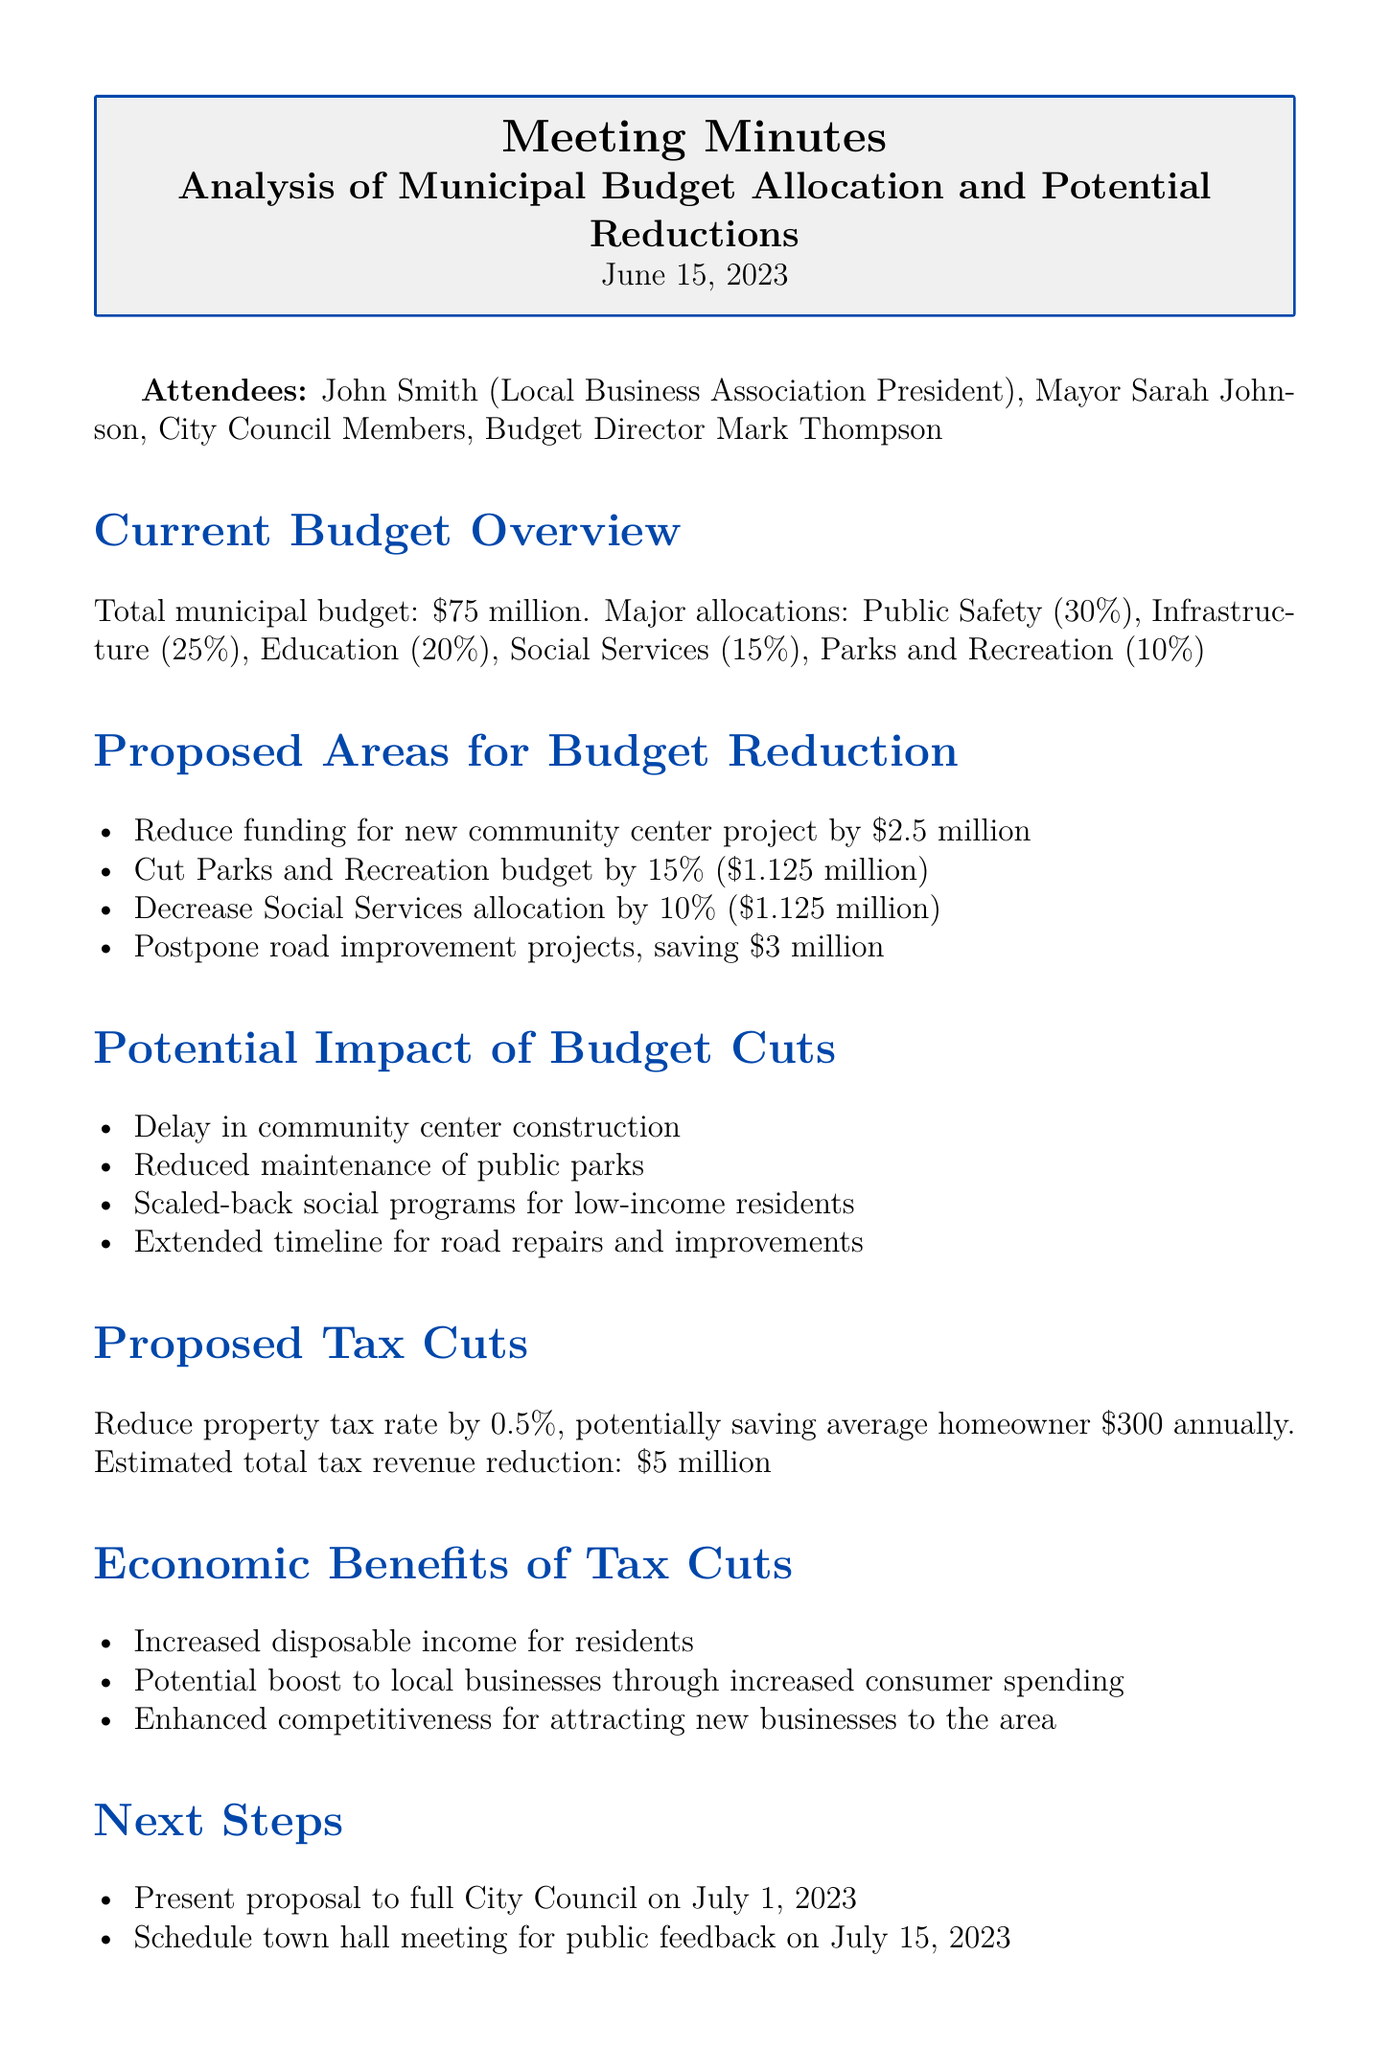what is the total municipal budget? The total municipal budget is clearly stated in the document as $75 million.
Answer: $75 million what percentage of the budget is allocated to Public Safety? The budget allocation for Public Safety is specifically mentioned as 30%.
Answer: 30% how much funding is proposed to reduce for the community center project? The document states a proposed reduction of $2.5 million for the community center project.
Answer: $2.5 million what is the potential annual savings for homeowners from the proposed tax cut? The document indicates that homeowners could save an average of $300 annually from the tax cut.
Answer: $300 what will be the estimated total tax revenue reduction? The document mentions that the estimated total tax revenue reduction will be $5 million.
Answer: $5 million what is one potential impact of the proposed budget cuts? It is mentioned that there will be a delay in community center construction as a potential impact of the budget cuts.
Answer: Delay in community center construction which date is scheduled for public feedback on the proposals? The document specifies the town hall meeting for public feedback is scheduled for July 15, 2023.
Answer: July 15, 2023 what is one economic benefit of the proposed tax cuts? One economic benefit mentioned in the document is increased disposable income for residents.
Answer: Increased disposable income how much will the Parks and Recreation budget be cut by? The budget for Parks and Recreation is proposed to be cut by 15%, amounting to $1.125 million.
Answer: $1.125 million 